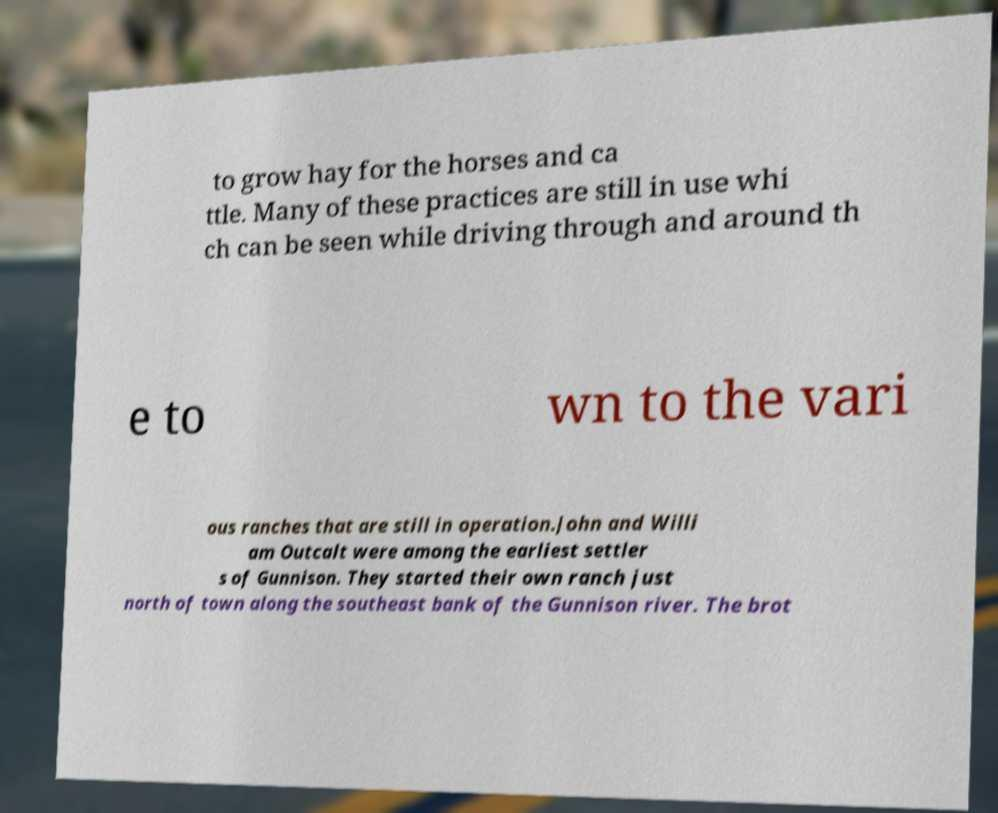Can you accurately transcribe the text from the provided image for me? to grow hay for the horses and ca ttle. Many of these practices are still in use whi ch can be seen while driving through and around th e to wn to the vari ous ranches that are still in operation.John and Willi am Outcalt were among the earliest settler s of Gunnison. They started their own ranch just north of town along the southeast bank of the Gunnison river. The brot 